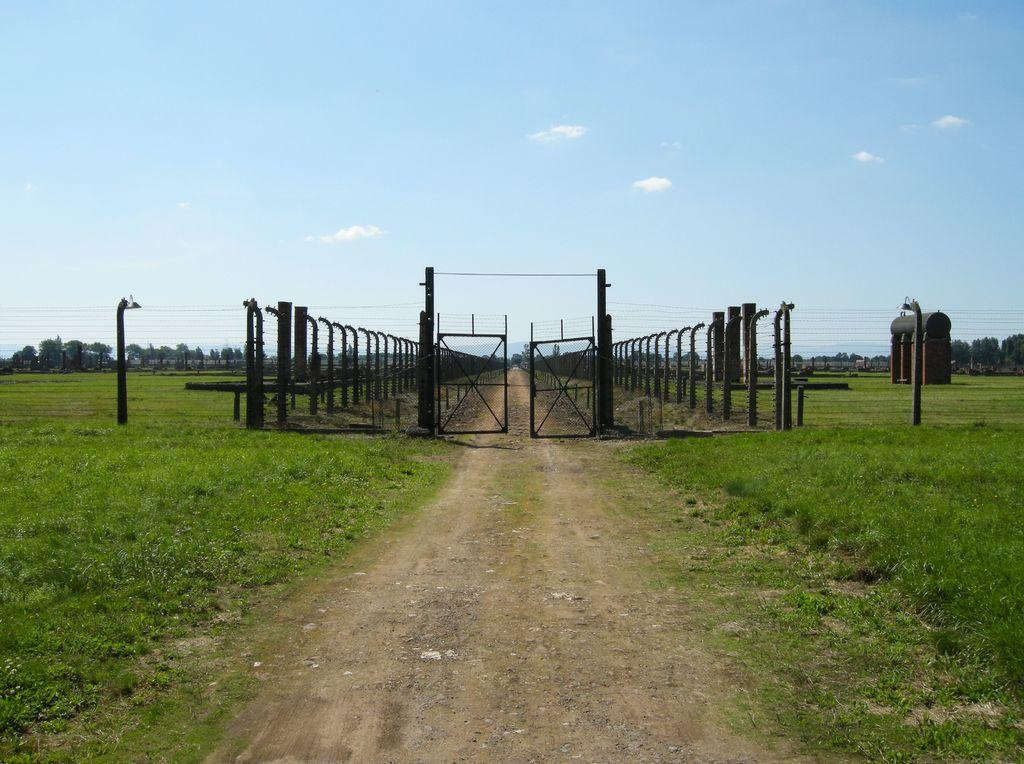What structures can be seen in the image? There are poles and a gate in the image. What else is present in the image besides the structures? There are wires, trees, a brown and black color object, green color grass, and the sky in white and blue color in the image. Can you tell me the name of the boy in the image? There is no boy present in the image. What type of receipt can be seen in the image? There is no receipt present in the image. 